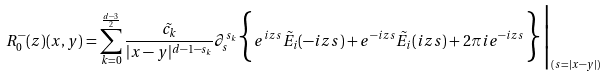<formula> <loc_0><loc_0><loc_500><loc_500>R ^ { - } _ { 0 } ( z ) ( x , y ) = \sum _ { k = 0 } ^ { \frac { d - 3 } { 2 } } \frac { \tilde { c _ { k } } } { | x - y | ^ { d - 1 - s _ { k } } } \partial _ { s } ^ { s _ { k } } \Big \{ e ^ { i z s } \tilde { E } _ { i } ( - i z s ) + e ^ { - i z s } \tilde { E } _ { i } ( i z s ) + 2 \pi i e ^ { - i z s } \Big \} \Big | _ { ( s = | x - y | ) }</formula> 